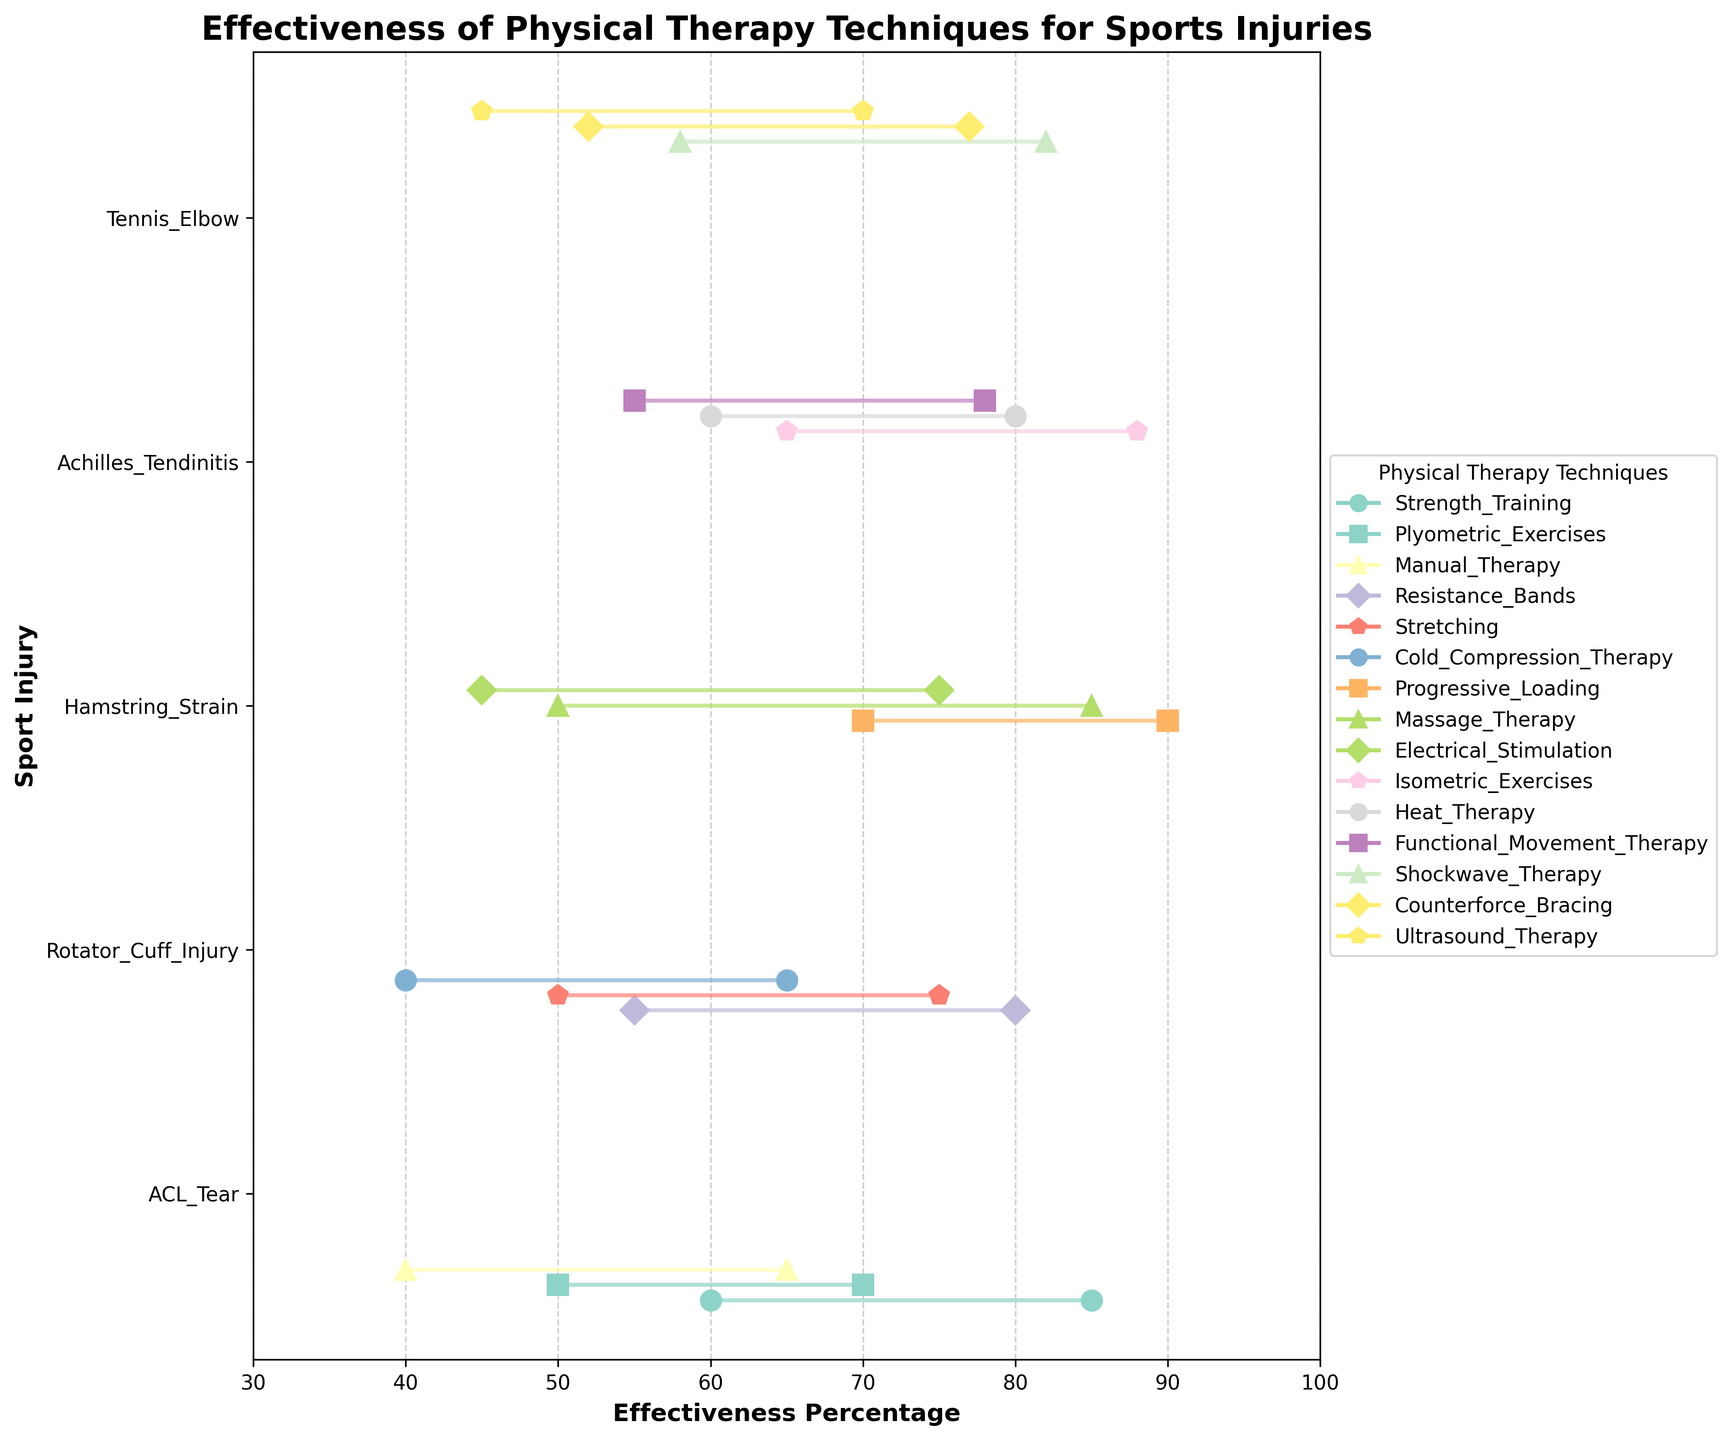What is the overall effectiveness range for Strength Training in treating ACL Tears? Look for the data points associated with Strength Training for ACL Tears. The minimum effectiveness is 60% and the maximum is 85%.
Answer: 60%-85% Which physical therapy technique has the highest maximum effectiveness for treating Hamstring Strain? Examine the maximum effectiveness percentages for each physical therapy technique listed under Hamstring Strain. Progressive Loading has the highest maximum effectiveness at 90%.
Answer: Progressive Loading How do the minimum effectiveness percentages for Shockwave Therapy and Ultrasound Therapy compare for treating Tennis Elbow? Find the minimum effectiveness percentages for both Shockwave Therapy and Ultrasound Therapy for Tennis Elbow. Shockwave Therapy is at 58%, while Ultrasound Therapy is at 45%.
Answer: Shockwave Therapy is higher What is the effectiveness range of Heat Therapy for treating Achilles Tendinitis? Locate the Heat Therapy data points under Achilles Tendinitis. The minimum effectiveness is 60%, and the maximum effectiveness is 80%.
Answer: 60%-80% What is the title of the plot? Look at the top of the plot where the title stating the main subject of the figure is located. The title is "Effectiveness of Physical Therapy Techniques for Sports Injuries".
Answer: Effectiveness of Physical Therapy Techniques for Sports Injuries Which injury has the broadest range of effectiveness for any single physical therapy technique? Compare the range (difference between maximum and minimum effectiveness) for each technique across all injuries. Hamstring Strain treated with Progressive Loading has the broadest range of 20% (90%-70%).
Answer: Hamstring Strain with Progressive Loading What is the maximum effectiveness percentage for the Stretching technique in treating Rotator Cuff Injuries? Identify the visual dot representing the maximum effectiveness of Stretching for Rotator Cuff Injuries. The maximum effectiveness is 75%.
Answer: 75% Compare the overall effectiveness of Manual Therapy and Cold Compression Therapy for ACL Tears and Rotator Cuff Injuries, respectively. Manual Therapy for ACL Tear ranges from 40%-65%. Cold Compression Therapy for Rotator Cuff Injury ranges from 40%-65%. Both have the same ranges.
Answer: Equal ranges Which physical therapy technique for Achilles Tendinitis has the lowest minimum effectiveness? Look at the minimum effectiveness values for all techniques listed under Achilles Tendinitis. Functional Movement Therapy has the lowest minimum effectiveness at 55%.
Answer: Functional Movement Therapy What visual marker distinguishes the different physical therapy techniques on the plot? On the plot, each technique is represented by different markers and colors. Various shapes (e.g., circles, squares) and distinct colors are used to distinguish them.
Answer: Different markers and colors 